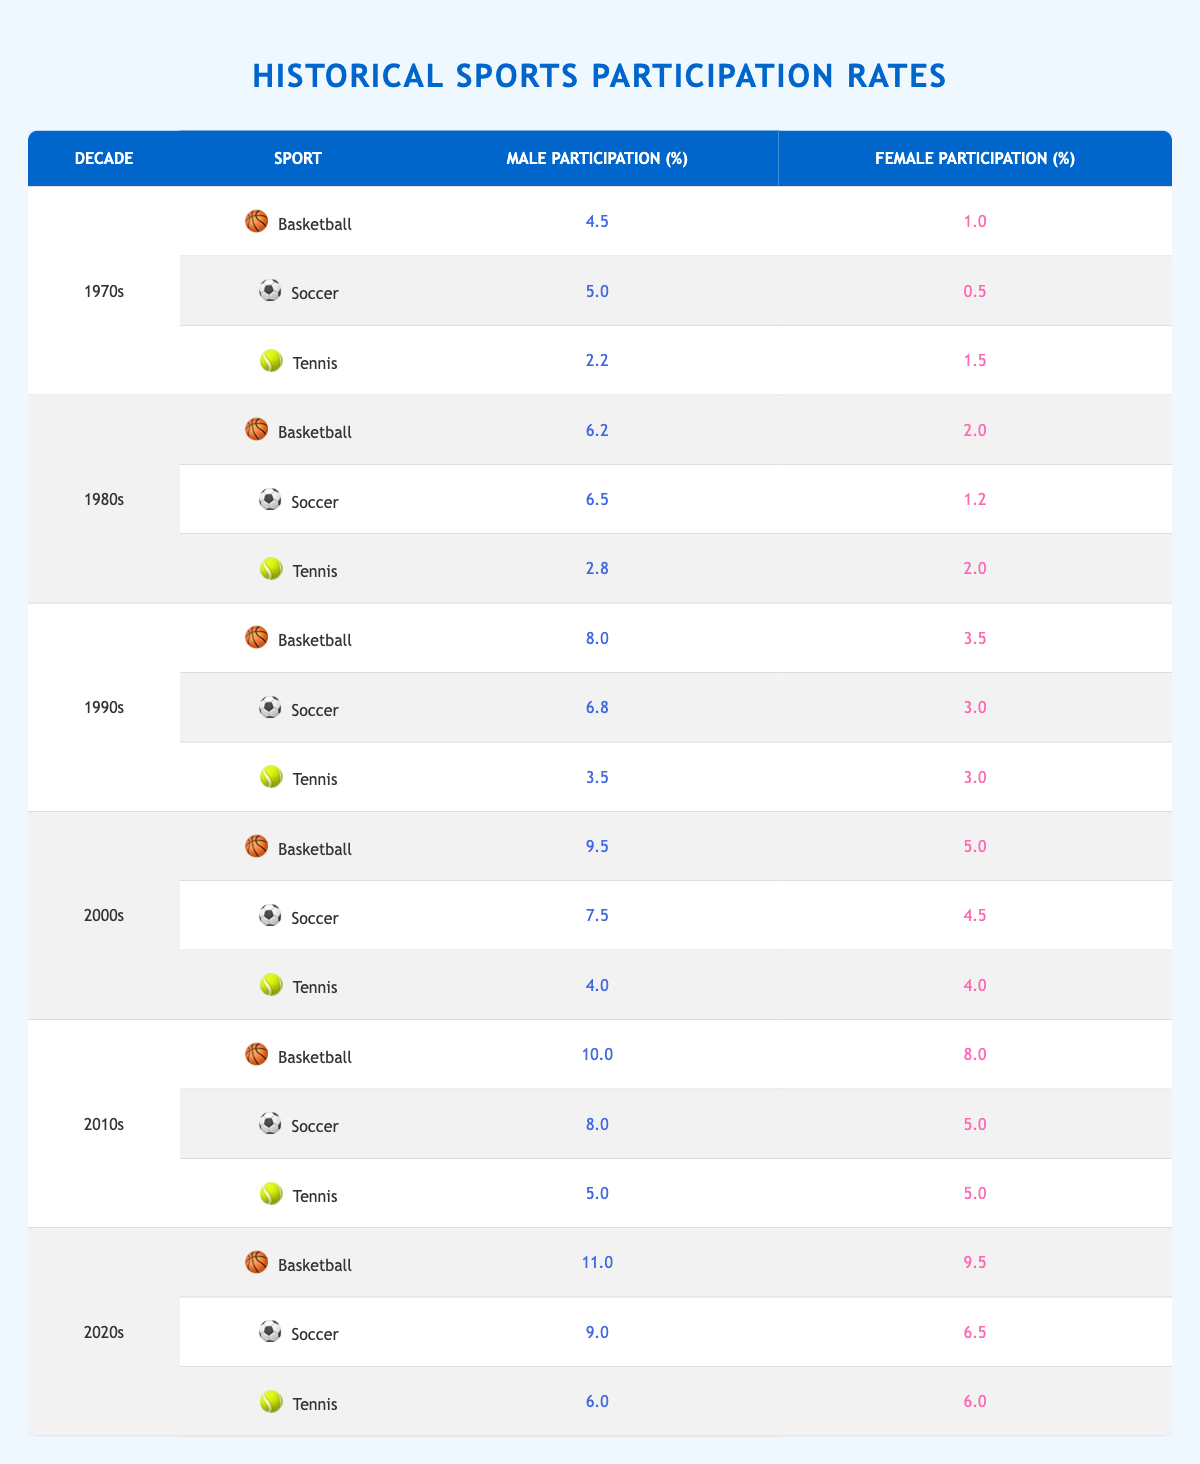What was the male participation rate in basketball in the 1990s? The table shows that in the 1990s, the male participation rate in basketball was 8.0%.
Answer: 8.0% What sport had the highest female participation rate in the 2000s? In the 2000s, tennis had the highest female participation rate at 4.0%.
Answer: Tennis Did female soccer participation increase or decrease from the 1970s to the 2020s? In the 1970s, female participation in soccer was 0.5%, and in the 2020s it increased to 6.5%, indicating an increase.
Answer: Increase What is the average male participation rate across all sports in the 1980s? The total male participation rates for basketball (6.2), soccer (6.5), and tennis (2.8) sum to 15.5. Dividing by 3 gives an average of 5.17.
Answer: 5.17 What was the difference in female participation rates in basketball between the 2010s and 2020s? The female participation rate in basketball was 8.0% in the 2010s and 9.5% in the 2020s. The difference is calculated as 9.5 - 8.0 = 1.5%.
Answer: 1.5% Has male participation in tennis ever been higher than female participation in the same sport during the 1980s? Yes, in the 1980s, male participation was 2.8%, while female participation was 2.0%. This indicates that male participation was higher.
Answer: Yes What sport saw the largest percentage growth in female participation from the 1970s to the 2020s? Calculating the change: Basketball increased from 1.0% to 9.5% (8.5% growth), Soccer from 0.5% to 6.5% (6.0% growth), and Tennis from 1.5% to 6.0% (4.5% growth). The largest growth was in Basketball.
Answer: Basketball Calculate the total male participation rate for soccer across all decades. To find the total for soccer: 5.0 (70s) + 6.5 (80s) + 6.8 (90s) + 7.5 (2000s) + 8.0 (2010s) + 9.0 (2020s) = 43.8%.
Answer: 43.8% Was the male participation in tennis higher than in basketball during the 2000s? In the 2000s, male participation in basketball was 9.5% while in tennis it was 4.0%, so basketball was higher.
Answer: No Which decade had the highest overall male participation rate in tennis? The male participation rates in tennis were 2.2% in the 1970s, 2.8% in the 1980s, 3.5% in the 1990s, 4.0% in the 2000s, 5.0% in the 2010s, and 6.0% in the 2020s. The highest was in the 2020s at 6.0%.
Answer: 2020s What percentage of female participants played basketball in the 1990s compared to the overall participation rate in tennis that decade? Female participation in basketball in the 1990s was 3.5%, and in tennis it was also 3.0%. Comparing them, basketball had more female participants by 0.5%.
Answer: 0.5% more in Basketball 